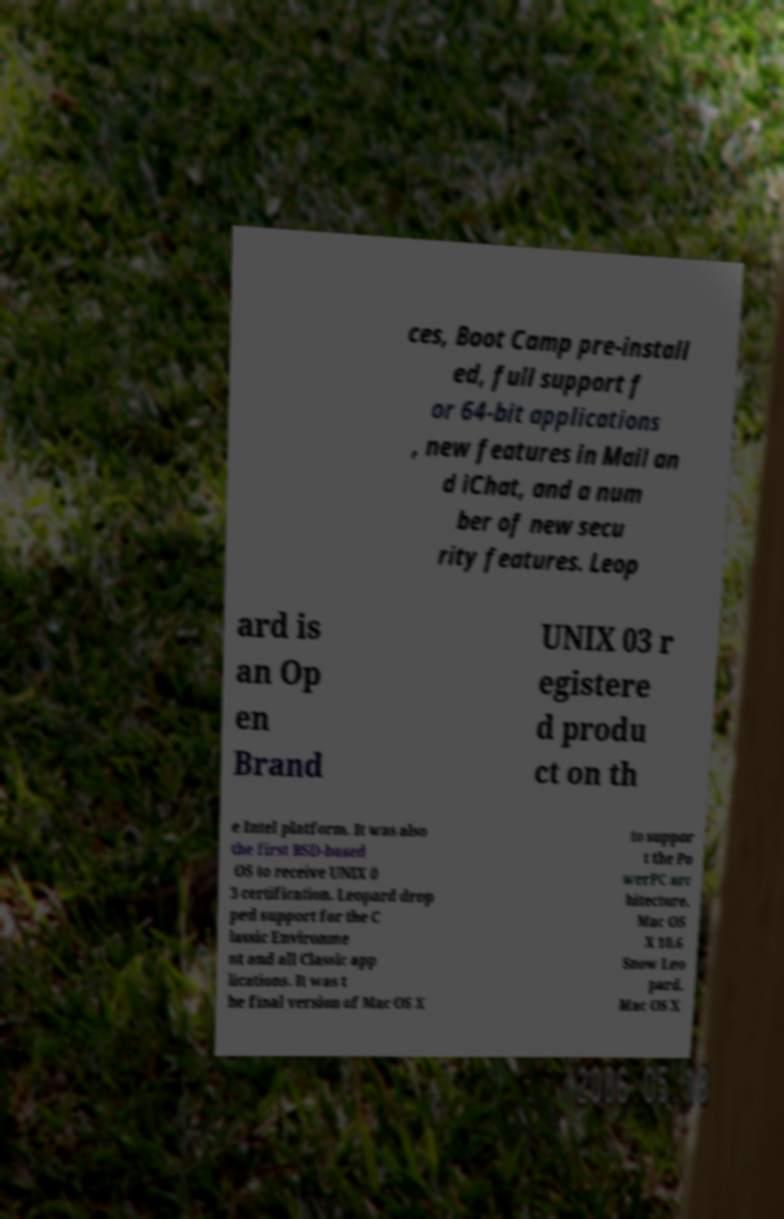For documentation purposes, I need the text within this image transcribed. Could you provide that? ces, Boot Camp pre-install ed, full support f or 64-bit applications , new features in Mail an d iChat, and a num ber of new secu rity features. Leop ard is an Op en Brand UNIX 03 r egistere d produ ct on th e Intel platform. It was also the first BSD-based OS to receive UNIX 0 3 certification. Leopard drop ped support for the C lassic Environme nt and all Classic app lications. It was t he final version of Mac OS X to suppor t the Po werPC arc hitecture. Mac OS X 10.6 Snow Leo pard. Mac OS X 